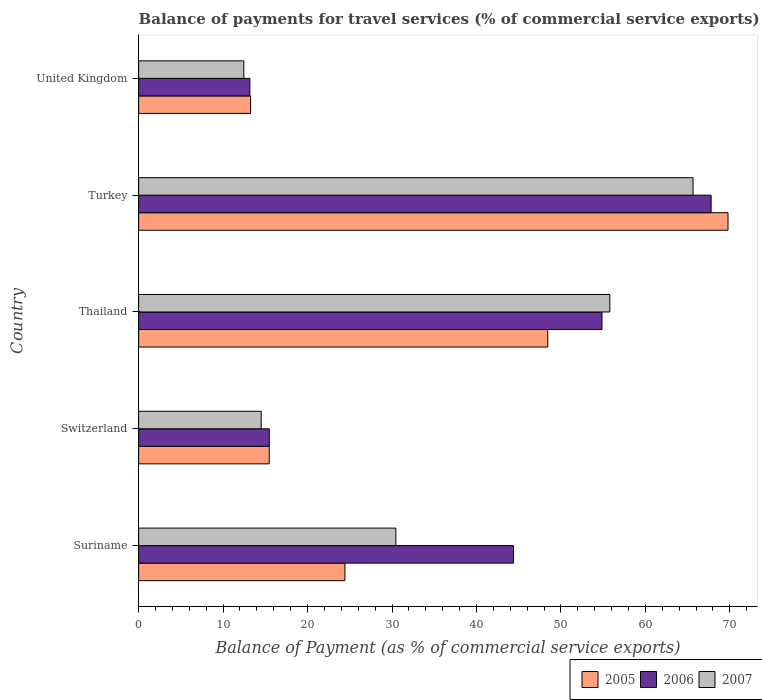How many different coloured bars are there?
Provide a short and direct response. 3. Are the number of bars per tick equal to the number of legend labels?
Your answer should be compact. Yes. How many bars are there on the 2nd tick from the bottom?
Your response must be concise. 3. What is the label of the 3rd group of bars from the top?
Your answer should be very brief. Thailand. In how many cases, is the number of bars for a given country not equal to the number of legend labels?
Your answer should be very brief. 0. What is the balance of payments for travel services in 2005 in United Kingdom?
Ensure brevity in your answer.  13.26. Across all countries, what is the maximum balance of payments for travel services in 2007?
Your answer should be compact. 65.64. Across all countries, what is the minimum balance of payments for travel services in 2006?
Make the answer very short. 13.17. In which country was the balance of payments for travel services in 2006 maximum?
Keep it short and to the point. Turkey. In which country was the balance of payments for travel services in 2005 minimum?
Keep it short and to the point. United Kingdom. What is the total balance of payments for travel services in 2006 in the graph?
Make the answer very short. 195.66. What is the difference between the balance of payments for travel services in 2007 in Switzerland and that in Thailand?
Ensure brevity in your answer.  -41.28. What is the difference between the balance of payments for travel services in 2005 in Suriname and the balance of payments for travel services in 2006 in Switzerland?
Ensure brevity in your answer.  8.95. What is the average balance of payments for travel services in 2006 per country?
Your answer should be very brief. 39.13. What is the difference between the balance of payments for travel services in 2006 and balance of payments for travel services in 2005 in Switzerland?
Your answer should be compact. 0.01. In how many countries, is the balance of payments for travel services in 2005 greater than 12 %?
Your answer should be very brief. 5. What is the ratio of the balance of payments for travel services in 2007 in Switzerland to that in Turkey?
Keep it short and to the point. 0.22. What is the difference between the highest and the second highest balance of payments for travel services in 2006?
Provide a succinct answer. 12.92. What is the difference between the highest and the lowest balance of payments for travel services in 2005?
Provide a short and direct response. 56.52. In how many countries, is the balance of payments for travel services in 2007 greater than the average balance of payments for travel services in 2007 taken over all countries?
Offer a terse response. 2. Is the sum of the balance of payments for travel services in 2007 in Switzerland and Thailand greater than the maximum balance of payments for travel services in 2005 across all countries?
Provide a short and direct response. Yes. Is it the case that in every country, the sum of the balance of payments for travel services in 2007 and balance of payments for travel services in 2006 is greater than the balance of payments for travel services in 2005?
Your response must be concise. Yes. How many countries are there in the graph?
Make the answer very short. 5. Where does the legend appear in the graph?
Offer a very short reply. Bottom right. What is the title of the graph?
Your answer should be very brief. Balance of payments for travel services (% of commercial service exports). Does "2009" appear as one of the legend labels in the graph?
Ensure brevity in your answer.  No. What is the label or title of the X-axis?
Provide a succinct answer. Balance of Payment (as % of commercial service exports). What is the Balance of Payment (as % of commercial service exports) in 2005 in Suriname?
Your response must be concise. 24.42. What is the Balance of Payment (as % of commercial service exports) in 2006 in Suriname?
Give a very brief answer. 44.38. What is the Balance of Payment (as % of commercial service exports) in 2007 in Suriname?
Offer a terse response. 30.45. What is the Balance of Payment (as % of commercial service exports) of 2005 in Switzerland?
Your answer should be compact. 15.46. What is the Balance of Payment (as % of commercial service exports) in 2006 in Switzerland?
Make the answer very short. 15.47. What is the Balance of Payment (as % of commercial service exports) in 2007 in Switzerland?
Your response must be concise. 14.51. What is the Balance of Payment (as % of commercial service exports) of 2005 in Thailand?
Give a very brief answer. 48.44. What is the Balance of Payment (as % of commercial service exports) of 2006 in Thailand?
Give a very brief answer. 54.86. What is the Balance of Payment (as % of commercial service exports) in 2007 in Thailand?
Offer a terse response. 55.79. What is the Balance of Payment (as % of commercial service exports) in 2005 in Turkey?
Your answer should be very brief. 69.78. What is the Balance of Payment (as % of commercial service exports) in 2006 in Turkey?
Make the answer very short. 67.78. What is the Balance of Payment (as % of commercial service exports) in 2007 in Turkey?
Your response must be concise. 65.64. What is the Balance of Payment (as % of commercial service exports) of 2005 in United Kingdom?
Your answer should be compact. 13.26. What is the Balance of Payment (as % of commercial service exports) of 2006 in United Kingdom?
Your answer should be compact. 13.17. What is the Balance of Payment (as % of commercial service exports) in 2007 in United Kingdom?
Provide a succinct answer. 12.45. Across all countries, what is the maximum Balance of Payment (as % of commercial service exports) in 2005?
Provide a short and direct response. 69.78. Across all countries, what is the maximum Balance of Payment (as % of commercial service exports) of 2006?
Give a very brief answer. 67.78. Across all countries, what is the maximum Balance of Payment (as % of commercial service exports) of 2007?
Your answer should be compact. 65.64. Across all countries, what is the minimum Balance of Payment (as % of commercial service exports) in 2005?
Keep it short and to the point. 13.26. Across all countries, what is the minimum Balance of Payment (as % of commercial service exports) of 2006?
Your answer should be very brief. 13.17. Across all countries, what is the minimum Balance of Payment (as % of commercial service exports) of 2007?
Provide a succinct answer. 12.45. What is the total Balance of Payment (as % of commercial service exports) of 2005 in the graph?
Your answer should be very brief. 171.36. What is the total Balance of Payment (as % of commercial service exports) of 2006 in the graph?
Your answer should be compact. 195.66. What is the total Balance of Payment (as % of commercial service exports) in 2007 in the graph?
Offer a very short reply. 178.84. What is the difference between the Balance of Payment (as % of commercial service exports) of 2005 in Suriname and that in Switzerland?
Provide a succinct answer. 8.96. What is the difference between the Balance of Payment (as % of commercial service exports) in 2006 in Suriname and that in Switzerland?
Provide a short and direct response. 28.91. What is the difference between the Balance of Payment (as % of commercial service exports) of 2007 in Suriname and that in Switzerland?
Provide a short and direct response. 15.94. What is the difference between the Balance of Payment (as % of commercial service exports) of 2005 in Suriname and that in Thailand?
Ensure brevity in your answer.  -24.01. What is the difference between the Balance of Payment (as % of commercial service exports) in 2006 in Suriname and that in Thailand?
Your answer should be compact. -10.48. What is the difference between the Balance of Payment (as % of commercial service exports) of 2007 in Suriname and that in Thailand?
Ensure brevity in your answer.  -25.33. What is the difference between the Balance of Payment (as % of commercial service exports) of 2005 in Suriname and that in Turkey?
Provide a succinct answer. -45.36. What is the difference between the Balance of Payment (as % of commercial service exports) in 2006 in Suriname and that in Turkey?
Offer a very short reply. -23.4. What is the difference between the Balance of Payment (as % of commercial service exports) of 2007 in Suriname and that in Turkey?
Provide a short and direct response. -35.19. What is the difference between the Balance of Payment (as % of commercial service exports) in 2005 in Suriname and that in United Kingdom?
Offer a terse response. 11.17. What is the difference between the Balance of Payment (as % of commercial service exports) in 2006 in Suriname and that in United Kingdom?
Your answer should be very brief. 31.21. What is the difference between the Balance of Payment (as % of commercial service exports) in 2007 in Suriname and that in United Kingdom?
Make the answer very short. 18. What is the difference between the Balance of Payment (as % of commercial service exports) of 2005 in Switzerland and that in Thailand?
Offer a terse response. -32.98. What is the difference between the Balance of Payment (as % of commercial service exports) of 2006 in Switzerland and that in Thailand?
Ensure brevity in your answer.  -39.39. What is the difference between the Balance of Payment (as % of commercial service exports) of 2007 in Switzerland and that in Thailand?
Your answer should be very brief. -41.28. What is the difference between the Balance of Payment (as % of commercial service exports) in 2005 in Switzerland and that in Turkey?
Offer a very short reply. -54.32. What is the difference between the Balance of Payment (as % of commercial service exports) of 2006 in Switzerland and that in Turkey?
Ensure brevity in your answer.  -52.31. What is the difference between the Balance of Payment (as % of commercial service exports) in 2007 in Switzerland and that in Turkey?
Offer a very short reply. -51.13. What is the difference between the Balance of Payment (as % of commercial service exports) in 2005 in Switzerland and that in United Kingdom?
Your answer should be very brief. 2.21. What is the difference between the Balance of Payment (as % of commercial service exports) of 2006 in Switzerland and that in United Kingdom?
Your answer should be compact. 2.3. What is the difference between the Balance of Payment (as % of commercial service exports) in 2007 in Switzerland and that in United Kingdom?
Offer a terse response. 2.06. What is the difference between the Balance of Payment (as % of commercial service exports) of 2005 in Thailand and that in Turkey?
Your response must be concise. -21.34. What is the difference between the Balance of Payment (as % of commercial service exports) in 2006 in Thailand and that in Turkey?
Your answer should be very brief. -12.92. What is the difference between the Balance of Payment (as % of commercial service exports) of 2007 in Thailand and that in Turkey?
Offer a terse response. -9.85. What is the difference between the Balance of Payment (as % of commercial service exports) in 2005 in Thailand and that in United Kingdom?
Your answer should be very brief. 35.18. What is the difference between the Balance of Payment (as % of commercial service exports) of 2006 in Thailand and that in United Kingdom?
Provide a succinct answer. 41.69. What is the difference between the Balance of Payment (as % of commercial service exports) of 2007 in Thailand and that in United Kingdom?
Give a very brief answer. 43.34. What is the difference between the Balance of Payment (as % of commercial service exports) of 2005 in Turkey and that in United Kingdom?
Provide a succinct answer. 56.52. What is the difference between the Balance of Payment (as % of commercial service exports) in 2006 in Turkey and that in United Kingdom?
Ensure brevity in your answer.  54.61. What is the difference between the Balance of Payment (as % of commercial service exports) of 2007 in Turkey and that in United Kingdom?
Provide a succinct answer. 53.19. What is the difference between the Balance of Payment (as % of commercial service exports) in 2005 in Suriname and the Balance of Payment (as % of commercial service exports) in 2006 in Switzerland?
Offer a terse response. 8.95. What is the difference between the Balance of Payment (as % of commercial service exports) in 2005 in Suriname and the Balance of Payment (as % of commercial service exports) in 2007 in Switzerland?
Give a very brief answer. 9.91. What is the difference between the Balance of Payment (as % of commercial service exports) in 2006 in Suriname and the Balance of Payment (as % of commercial service exports) in 2007 in Switzerland?
Your answer should be compact. 29.87. What is the difference between the Balance of Payment (as % of commercial service exports) of 2005 in Suriname and the Balance of Payment (as % of commercial service exports) of 2006 in Thailand?
Give a very brief answer. -30.43. What is the difference between the Balance of Payment (as % of commercial service exports) in 2005 in Suriname and the Balance of Payment (as % of commercial service exports) in 2007 in Thailand?
Offer a terse response. -31.36. What is the difference between the Balance of Payment (as % of commercial service exports) in 2006 in Suriname and the Balance of Payment (as % of commercial service exports) in 2007 in Thailand?
Your answer should be very brief. -11.4. What is the difference between the Balance of Payment (as % of commercial service exports) in 2005 in Suriname and the Balance of Payment (as % of commercial service exports) in 2006 in Turkey?
Provide a short and direct response. -43.35. What is the difference between the Balance of Payment (as % of commercial service exports) in 2005 in Suriname and the Balance of Payment (as % of commercial service exports) in 2007 in Turkey?
Provide a succinct answer. -41.21. What is the difference between the Balance of Payment (as % of commercial service exports) in 2006 in Suriname and the Balance of Payment (as % of commercial service exports) in 2007 in Turkey?
Your answer should be compact. -21.26. What is the difference between the Balance of Payment (as % of commercial service exports) in 2005 in Suriname and the Balance of Payment (as % of commercial service exports) in 2006 in United Kingdom?
Ensure brevity in your answer.  11.25. What is the difference between the Balance of Payment (as % of commercial service exports) in 2005 in Suriname and the Balance of Payment (as % of commercial service exports) in 2007 in United Kingdom?
Your response must be concise. 11.97. What is the difference between the Balance of Payment (as % of commercial service exports) of 2006 in Suriname and the Balance of Payment (as % of commercial service exports) of 2007 in United Kingdom?
Offer a terse response. 31.93. What is the difference between the Balance of Payment (as % of commercial service exports) in 2005 in Switzerland and the Balance of Payment (as % of commercial service exports) in 2006 in Thailand?
Your response must be concise. -39.4. What is the difference between the Balance of Payment (as % of commercial service exports) of 2005 in Switzerland and the Balance of Payment (as % of commercial service exports) of 2007 in Thailand?
Ensure brevity in your answer.  -40.33. What is the difference between the Balance of Payment (as % of commercial service exports) of 2006 in Switzerland and the Balance of Payment (as % of commercial service exports) of 2007 in Thailand?
Ensure brevity in your answer.  -40.31. What is the difference between the Balance of Payment (as % of commercial service exports) in 2005 in Switzerland and the Balance of Payment (as % of commercial service exports) in 2006 in Turkey?
Your response must be concise. -52.32. What is the difference between the Balance of Payment (as % of commercial service exports) in 2005 in Switzerland and the Balance of Payment (as % of commercial service exports) in 2007 in Turkey?
Ensure brevity in your answer.  -50.18. What is the difference between the Balance of Payment (as % of commercial service exports) of 2006 in Switzerland and the Balance of Payment (as % of commercial service exports) of 2007 in Turkey?
Your answer should be very brief. -50.17. What is the difference between the Balance of Payment (as % of commercial service exports) in 2005 in Switzerland and the Balance of Payment (as % of commercial service exports) in 2006 in United Kingdom?
Give a very brief answer. 2.29. What is the difference between the Balance of Payment (as % of commercial service exports) in 2005 in Switzerland and the Balance of Payment (as % of commercial service exports) in 2007 in United Kingdom?
Your answer should be very brief. 3.01. What is the difference between the Balance of Payment (as % of commercial service exports) of 2006 in Switzerland and the Balance of Payment (as % of commercial service exports) of 2007 in United Kingdom?
Keep it short and to the point. 3.02. What is the difference between the Balance of Payment (as % of commercial service exports) in 2005 in Thailand and the Balance of Payment (as % of commercial service exports) in 2006 in Turkey?
Your answer should be very brief. -19.34. What is the difference between the Balance of Payment (as % of commercial service exports) in 2005 in Thailand and the Balance of Payment (as % of commercial service exports) in 2007 in Turkey?
Your answer should be compact. -17.2. What is the difference between the Balance of Payment (as % of commercial service exports) in 2006 in Thailand and the Balance of Payment (as % of commercial service exports) in 2007 in Turkey?
Give a very brief answer. -10.78. What is the difference between the Balance of Payment (as % of commercial service exports) of 2005 in Thailand and the Balance of Payment (as % of commercial service exports) of 2006 in United Kingdom?
Give a very brief answer. 35.27. What is the difference between the Balance of Payment (as % of commercial service exports) in 2005 in Thailand and the Balance of Payment (as % of commercial service exports) in 2007 in United Kingdom?
Offer a terse response. 35.99. What is the difference between the Balance of Payment (as % of commercial service exports) in 2006 in Thailand and the Balance of Payment (as % of commercial service exports) in 2007 in United Kingdom?
Ensure brevity in your answer.  42.41. What is the difference between the Balance of Payment (as % of commercial service exports) in 2005 in Turkey and the Balance of Payment (as % of commercial service exports) in 2006 in United Kingdom?
Provide a short and direct response. 56.61. What is the difference between the Balance of Payment (as % of commercial service exports) of 2005 in Turkey and the Balance of Payment (as % of commercial service exports) of 2007 in United Kingdom?
Your response must be concise. 57.33. What is the difference between the Balance of Payment (as % of commercial service exports) in 2006 in Turkey and the Balance of Payment (as % of commercial service exports) in 2007 in United Kingdom?
Keep it short and to the point. 55.33. What is the average Balance of Payment (as % of commercial service exports) of 2005 per country?
Your response must be concise. 34.27. What is the average Balance of Payment (as % of commercial service exports) in 2006 per country?
Keep it short and to the point. 39.13. What is the average Balance of Payment (as % of commercial service exports) in 2007 per country?
Give a very brief answer. 35.77. What is the difference between the Balance of Payment (as % of commercial service exports) in 2005 and Balance of Payment (as % of commercial service exports) in 2006 in Suriname?
Your response must be concise. -19.96. What is the difference between the Balance of Payment (as % of commercial service exports) of 2005 and Balance of Payment (as % of commercial service exports) of 2007 in Suriname?
Provide a succinct answer. -6.03. What is the difference between the Balance of Payment (as % of commercial service exports) of 2006 and Balance of Payment (as % of commercial service exports) of 2007 in Suriname?
Your answer should be very brief. 13.93. What is the difference between the Balance of Payment (as % of commercial service exports) of 2005 and Balance of Payment (as % of commercial service exports) of 2006 in Switzerland?
Provide a succinct answer. -0.01. What is the difference between the Balance of Payment (as % of commercial service exports) in 2005 and Balance of Payment (as % of commercial service exports) in 2007 in Switzerland?
Ensure brevity in your answer.  0.95. What is the difference between the Balance of Payment (as % of commercial service exports) in 2006 and Balance of Payment (as % of commercial service exports) in 2007 in Switzerland?
Your answer should be compact. 0.96. What is the difference between the Balance of Payment (as % of commercial service exports) in 2005 and Balance of Payment (as % of commercial service exports) in 2006 in Thailand?
Give a very brief answer. -6.42. What is the difference between the Balance of Payment (as % of commercial service exports) of 2005 and Balance of Payment (as % of commercial service exports) of 2007 in Thailand?
Give a very brief answer. -7.35. What is the difference between the Balance of Payment (as % of commercial service exports) of 2006 and Balance of Payment (as % of commercial service exports) of 2007 in Thailand?
Provide a succinct answer. -0.93. What is the difference between the Balance of Payment (as % of commercial service exports) of 2005 and Balance of Payment (as % of commercial service exports) of 2006 in Turkey?
Make the answer very short. 2. What is the difference between the Balance of Payment (as % of commercial service exports) of 2005 and Balance of Payment (as % of commercial service exports) of 2007 in Turkey?
Offer a very short reply. 4.14. What is the difference between the Balance of Payment (as % of commercial service exports) of 2006 and Balance of Payment (as % of commercial service exports) of 2007 in Turkey?
Make the answer very short. 2.14. What is the difference between the Balance of Payment (as % of commercial service exports) in 2005 and Balance of Payment (as % of commercial service exports) in 2006 in United Kingdom?
Your response must be concise. 0.08. What is the difference between the Balance of Payment (as % of commercial service exports) in 2005 and Balance of Payment (as % of commercial service exports) in 2007 in United Kingdom?
Your answer should be very brief. 0.8. What is the difference between the Balance of Payment (as % of commercial service exports) of 2006 and Balance of Payment (as % of commercial service exports) of 2007 in United Kingdom?
Provide a short and direct response. 0.72. What is the ratio of the Balance of Payment (as % of commercial service exports) of 2005 in Suriname to that in Switzerland?
Give a very brief answer. 1.58. What is the ratio of the Balance of Payment (as % of commercial service exports) of 2006 in Suriname to that in Switzerland?
Keep it short and to the point. 2.87. What is the ratio of the Balance of Payment (as % of commercial service exports) in 2007 in Suriname to that in Switzerland?
Provide a short and direct response. 2.1. What is the ratio of the Balance of Payment (as % of commercial service exports) of 2005 in Suriname to that in Thailand?
Offer a very short reply. 0.5. What is the ratio of the Balance of Payment (as % of commercial service exports) in 2006 in Suriname to that in Thailand?
Provide a succinct answer. 0.81. What is the ratio of the Balance of Payment (as % of commercial service exports) of 2007 in Suriname to that in Thailand?
Your response must be concise. 0.55. What is the ratio of the Balance of Payment (as % of commercial service exports) of 2006 in Suriname to that in Turkey?
Provide a succinct answer. 0.65. What is the ratio of the Balance of Payment (as % of commercial service exports) of 2007 in Suriname to that in Turkey?
Your answer should be very brief. 0.46. What is the ratio of the Balance of Payment (as % of commercial service exports) of 2005 in Suriname to that in United Kingdom?
Offer a very short reply. 1.84. What is the ratio of the Balance of Payment (as % of commercial service exports) of 2006 in Suriname to that in United Kingdom?
Provide a short and direct response. 3.37. What is the ratio of the Balance of Payment (as % of commercial service exports) in 2007 in Suriname to that in United Kingdom?
Offer a terse response. 2.45. What is the ratio of the Balance of Payment (as % of commercial service exports) of 2005 in Switzerland to that in Thailand?
Keep it short and to the point. 0.32. What is the ratio of the Balance of Payment (as % of commercial service exports) of 2006 in Switzerland to that in Thailand?
Your answer should be very brief. 0.28. What is the ratio of the Balance of Payment (as % of commercial service exports) of 2007 in Switzerland to that in Thailand?
Keep it short and to the point. 0.26. What is the ratio of the Balance of Payment (as % of commercial service exports) in 2005 in Switzerland to that in Turkey?
Give a very brief answer. 0.22. What is the ratio of the Balance of Payment (as % of commercial service exports) in 2006 in Switzerland to that in Turkey?
Provide a short and direct response. 0.23. What is the ratio of the Balance of Payment (as % of commercial service exports) in 2007 in Switzerland to that in Turkey?
Your answer should be compact. 0.22. What is the ratio of the Balance of Payment (as % of commercial service exports) in 2005 in Switzerland to that in United Kingdom?
Provide a succinct answer. 1.17. What is the ratio of the Balance of Payment (as % of commercial service exports) in 2006 in Switzerland to that in United Kingdom?
Ensure brevity in your answer.  1.17. What is the ratio of the Balance of Payment (as % of commercial service exports) in 2007 in Switzerland to that in United Kingdom?
Your answer should be very brief. 1.17. What is the ratio of the Balance of Payment (as % of commercial service exports) in 2005 in Thailand to that in Turkey?
Your response must be concise. 0.69. What is the ratio of the Balance of Payment (as % of commercial service exports) of 2006 in Thailand to that in Turkey?
Offer a terse response. 0.81. What is the ratio of the Balance of Payment (as % of commercial service exports) of 2007 in Thailand to that in Turkey?
Offer a very short reply. 0.85. What is the ratio of the Balance of Payment (as % of commercial service exports) in 2005 in Thailand to that in United Kingdom?
Provide a short and direct response. 3.65. What is the ratio of the Balance of Payment (as % of commercial service exports) in 2006 in Thailand to that in United Kingdom?
Give a very brief answer. 4.16. What is the ratio of the Balance of Payment (as % of commercial service exports) of 2007 in Thailand to that in United Kingdom?
Offer a very short reply. 4.48. What is the ratio of the Balance of Payment (as % of commercial service exports) in 2005 in Turkey to that in United Kingdom?
Offer a very short reply. 5.26. What is the ratio of the Balance of Payment (as % of commercial service exports) of 2006 in Turkey to that in United Kingdom?
Your answer should be very brief. 5.15. What is the ratio of the Balance of Payment (as % of commercial service exports) of 2007 in Turkey to that in United Kingdom?
Keep it short and to the point. 5.27. What is the difference between the highest and the second highest Balance of Payment (as % of commercial service exports) in 2005?
Make the answer very short. 21.34. What is the difference between the highest and the second highest Balance of Payment (as % of commercial service exports) of 2006?
Offer a terse response. 12.92. What is the difference between the highest and the second highest Balance of Payment (as % of commercial service exports) in 2007?
Keep it short and to the point. 9.85. What is the difference between the highest and the lowest Balance of Payment (as % of commercial service exports) of 2005?
Give a very brief answer. 56.52. What is the difference between the highest and the lowest Balance of Payment (as % of commercial service exports) in 2006?
Provide a succinct answer. 54.61. What is the difference between the highest and the lowest Balance of Payment (as % of commercial service exports) of 2007?
Offer a terse response. 53.19. 